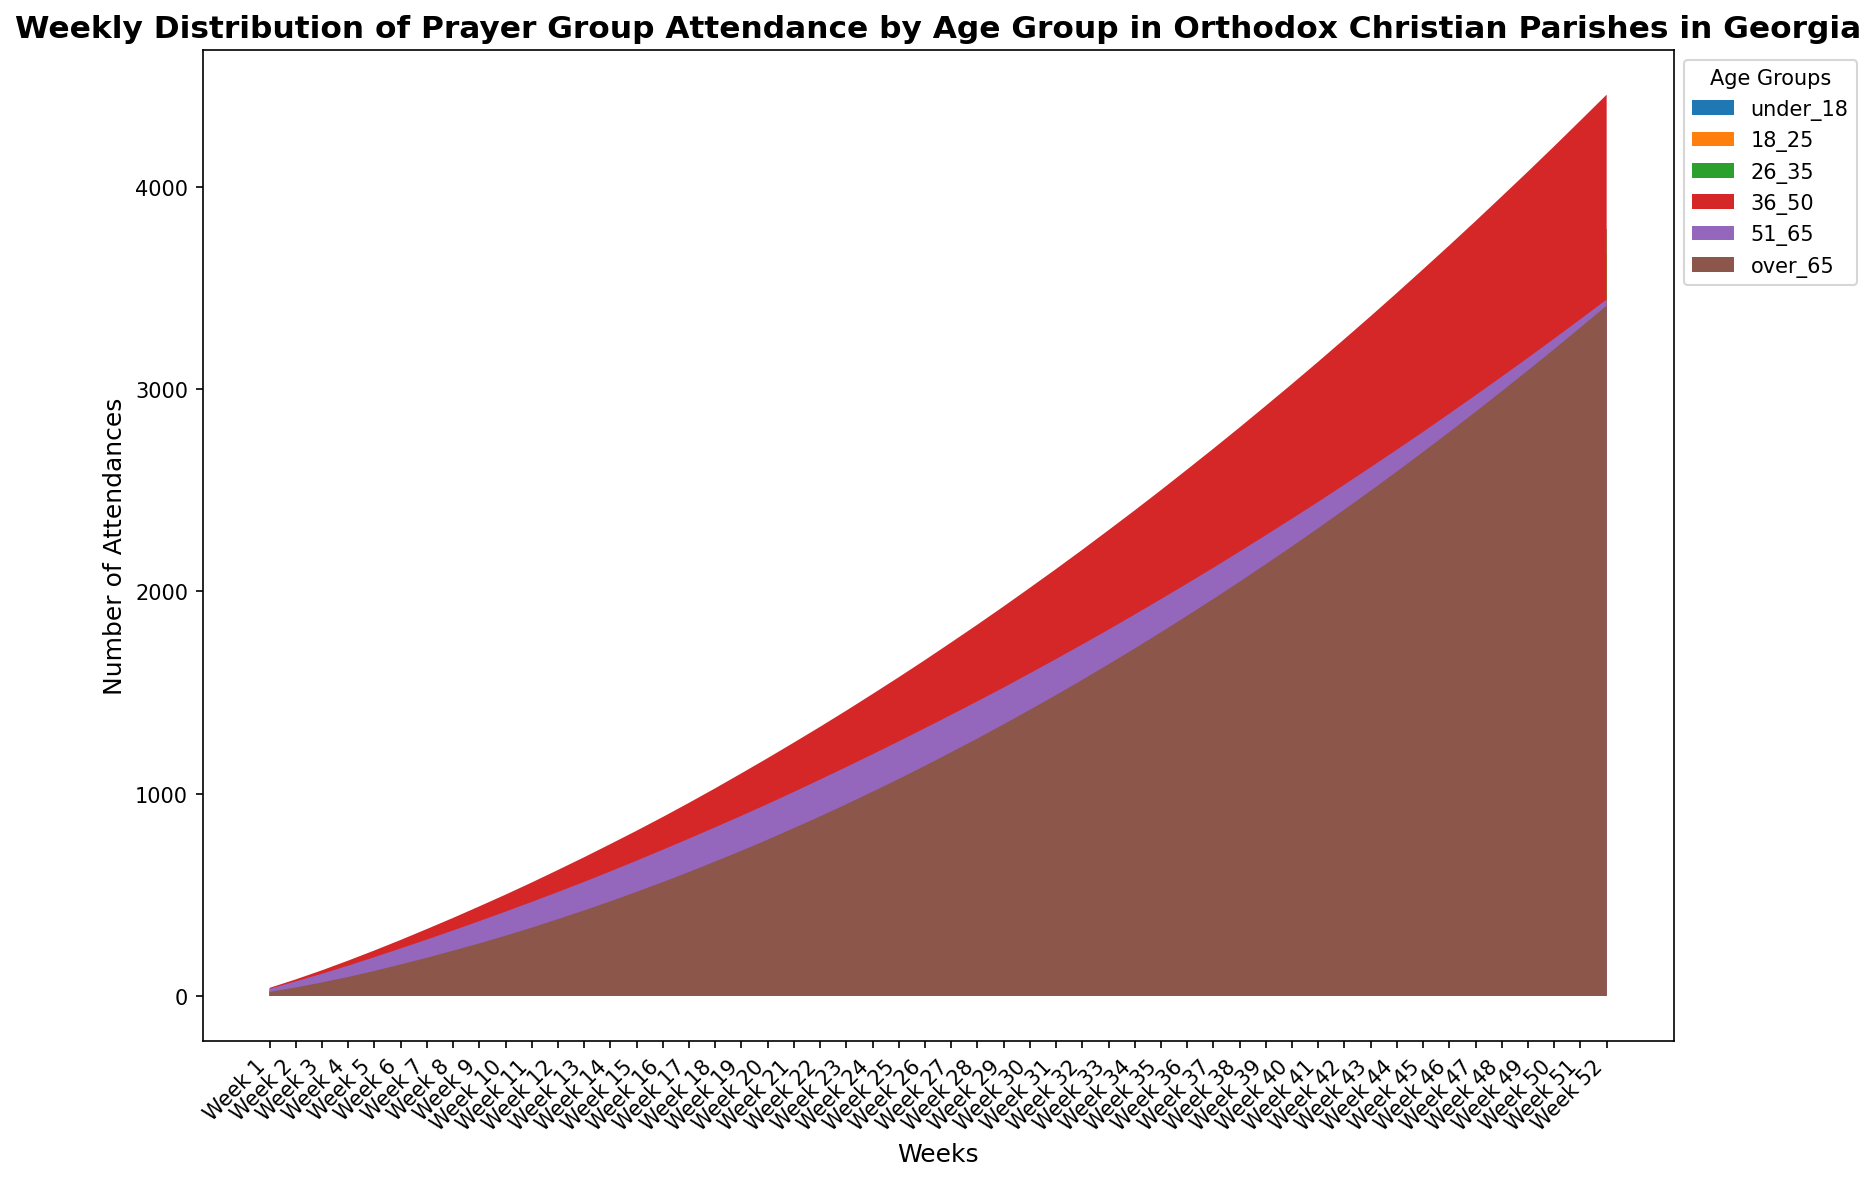How does the attendance of under 18 age group change from Week 1 to Week 52? To answer this, observe the attendance of the under 18 age group in Week 1 and compare it with Week 52. For Week 1, attendance is 15, and for Week 52, it is 103. The increase can be calculated as 103 - 15.
Answer: 88 In which week did the 36-50 age group have its first attendance of over 100? Observe the attendance figures for the 36-50 age group and identify the week when it crossed 100. The attendance reaches 102 in Week 36.
Answer: Week 36 What is the total attendance for the over 65 age group by Week 20? Sum the attendance of the over 65 age group from Week 1 to Week 20. Adding up the values (20+22+25+27+30+32+33+35+36+38+40+42+43+45+47+48+50+52+53+55) results in 724.
Answer: 724 Which age group had the highest attendance in Week 52? Compare the attendance numbers for Week 52 across all age groups. The values are: under 18 (103), 18-25 (113), 26-35 (114), 36-50 (128), 51-65 (97), and over 65 (108). The highest is 128, corresponding to the 36-50 age group.
Answer: 36-50 By approximately how many attendances did the 26-35 and 36-50 age groups differ in Week 30? Subtract the attendance of the 26-35 group (78) from the 36-50 group (92). The difference is 92 - 78.
Answer: 14 Does the attendance of the 18-25 age group show a steady increase, decrease, or fluctuation from Week 1 to Week 52? Observe the trend of the 18-25 age group attendance data over the weeks. The values increase from 25 in Week 1 to 113 in Week 52, indicating a steady increase.
Answer: Steady increase What is the median attendance for the 51-65 age group during the first 10 weeks? Sort the attendance values for the 51-65 age group from Week 1 to Week 10: (35, 37, 38, 40, 42, 43, 44, 45, 46, 47). The median is the middle value of the sorted list, which is (42 + 43)/2.
Answer: 42.5 How did the attendance of the 18-25 age group compare to the 36-50 age group in Week 15? Compare the attendance numbers of 18-25 (52) with 36-50 (66). The 36-50 age group had a higher attendance than the 18-25 age group.
Answer: 36-50 What is the average attendance for the over 65 age group across all 52 weeks? Sum the attendance values of the over 65 age group from Week 1 to Week 52 and divide by 52: (20+22+25+27+30+32+33+35+36+38+40+42+43+45+47+48+50+52+53+55+57+58+60+62+63+65+67+68+70+72+73+75+77+78+80+82+83+85+87+88+90+92+93+95+97+98+100+102+103+105+107+108) / 52 = 66.5.
Answer: 66.5 